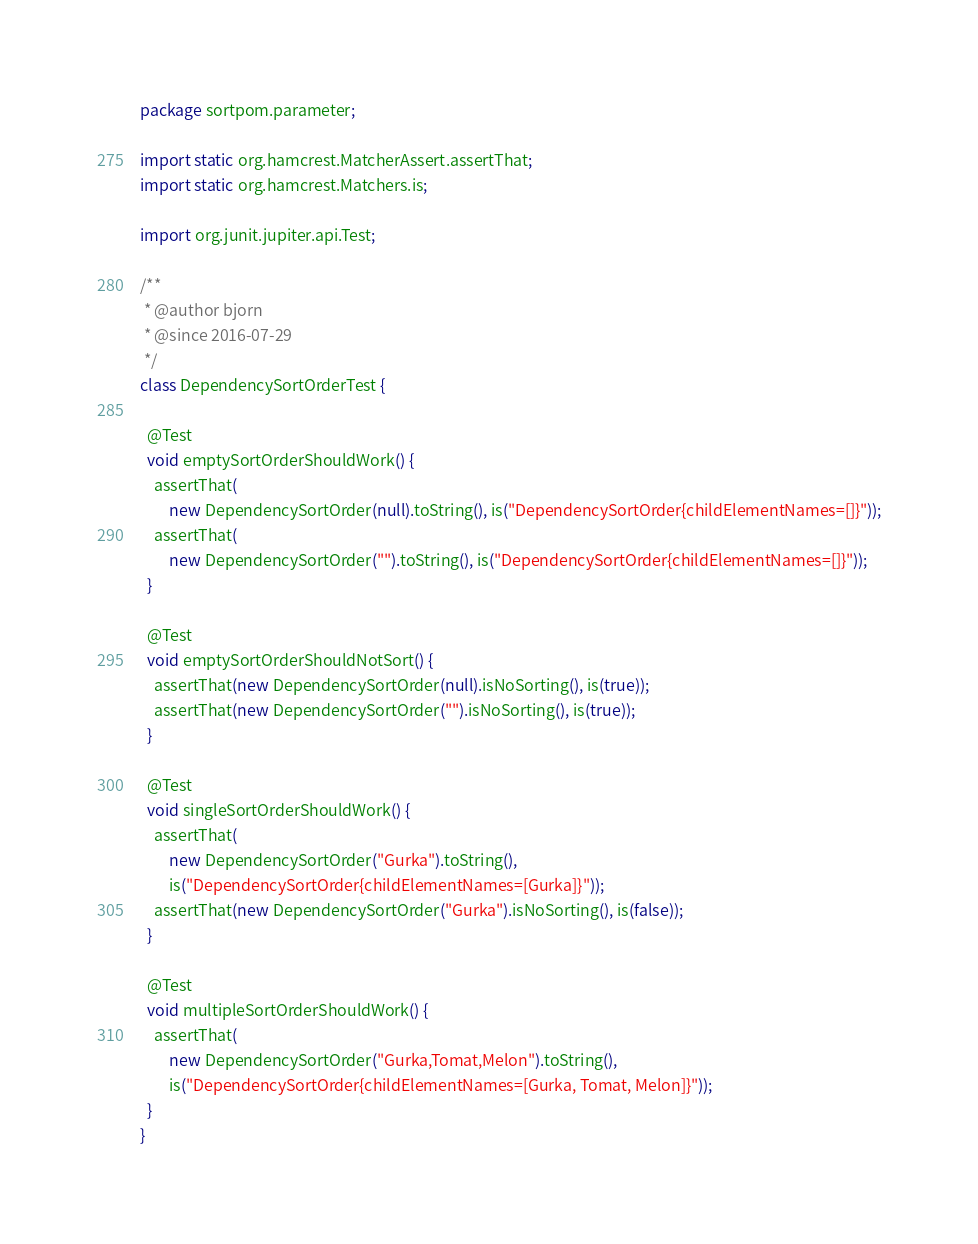Convert code to text. <code><loc_0><loc_0><loc_500><loc_500><_Java_>package sortpom.parameter;

import static org.hamcrest.MatcherAssert.assertThat;
import static org.hamcrest.Matchers.is;

import org.junit.jupiter.api.Test;

/**
 * @author bjorn
 * @since 2016-07-29
 */
class DependencySortOrderTest {

  @Test
  void emptySortOrderShouldWork() {
    assertThat(
        new DependencySortOrder(null).toString(), is("DependencySortOrder{childElementNames=[]}"));
    assertThat(
        new DependencySortOrder("").toString(), is("DependencySortOrder{childElementNames=[]}"));
  }

  @Test
  void emptySortOrderShouldNotSort() {
    assertThat(new DependencySortOrder(null).isNoSorting(), is(true));
    assertThat(new DependencySortOrder("").isNoSorting(), is(true));
  }

  @Test
  void singleSortOrderShouldWork() {
    assertThat(
        new DependencySortOrder("Gurka").toString(),
        is("DependencySortOrder{childElementNames=[Gurka]}"));
    assertThat(new DependencySortOrder("Gurka").isNoSorting(), is(false));
  }

  @Test
  void multipleSortOrderShouldWork() {
    assertThat(
        new DependencySortOrder("Gurka,Tomat,Melon").toString(),
        is("DependencySortOrder{childElementNames=[Gurka, Tomat, Melon]}"));
  }
}
</code> 